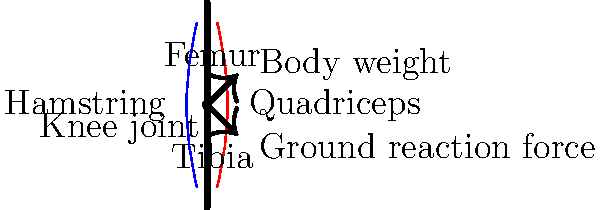During a steep uphill hike, you feel increased pressure on your knee joints. Considering the mechanical stress on the knee, which muscle group plays a crucial role in reducing this stress and protecting the joint? To understand the mechanical stress on knee joints during hiking, let's break down the forces and muscle actions involved:

1. Body weight: When hiking uphill, the body weight creates a downward force on the knee joint.

2. Ground reaction force: The ground pushes back with an equal and opposite force, which is directed upward through the leg.

3. Knee joint stress: The combination of these forces creates stress on the knee joint, particularly during the stance phase of walking.

4. Muscle action:
   a) Quadriceps (front thigh muscles): These muscles contract eccentrically (lengthening while contracting) during downhill walking to control knee flexion.
   b) Hamstrings (back thigh muscles): These muscles work to extend the hip and flex the knee during the gait cycle.

5. Stress reduction: The quadriceps play a crucial role in reducing stress on the knee joint by:
   a) Providing stability to the knee joint
   b) Absorbing shock during impact
   c) Controlling the rate of knee flexion, especially during downhill walking

6. Protection mechanism: By controlling knee flexion and providing stability, the quadriceps help distribute forces more evenly across the joint surface, reducing the risk of injury and wear on the cartilage.

7. Hiking adaptation: Regular hikers often develop stronger quadriceps, which can lead to better knee joint protection and reduced pain during long hikes.

Therefore, the quadriceps muscle group is essential in reducing mechanical stress on the knee joint during hiking, particularly on steep terrain.
Answer: Quadriceps 